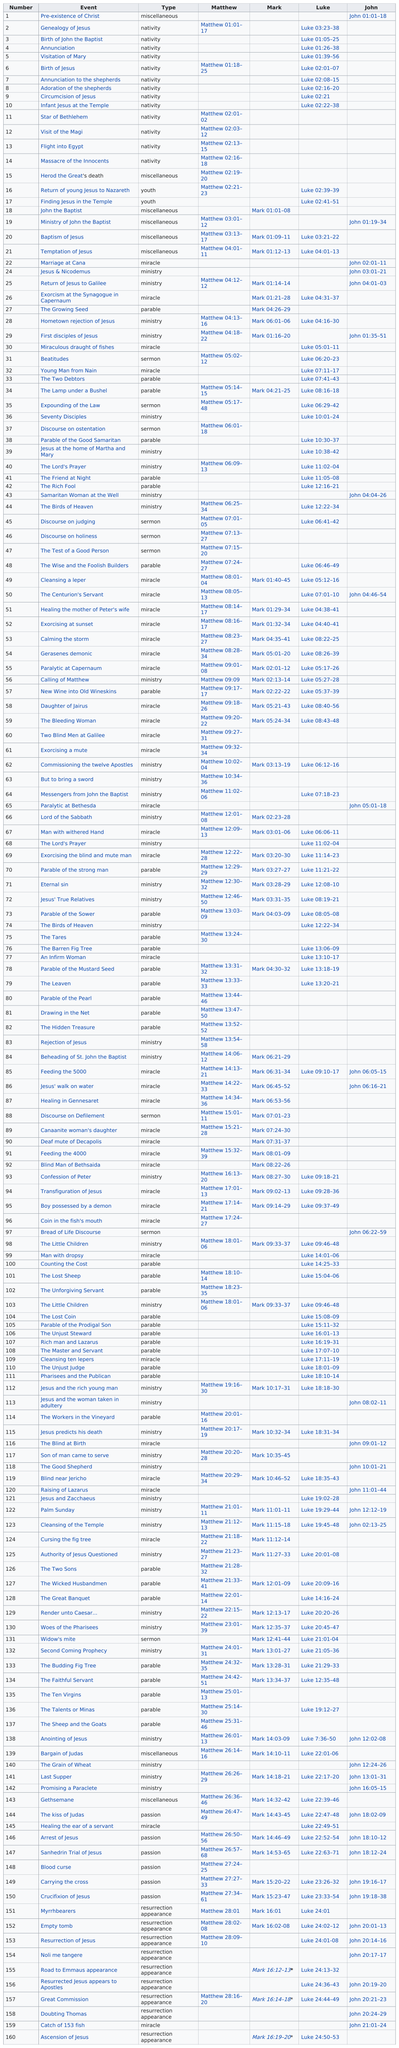Specify some key components in this picture. The event that comes before Luke 1:26-38 is the birth of John the Baptist. The person who was the only one to discuss the pre-existence of Christ was John. John describes 34 events in his account. The resurrected Jesus appeared to the apostles, a event mentioned by both Luke and John but not in Matthew and Mark. The longest consecutive amount of topics that Luke writes about is 12. 